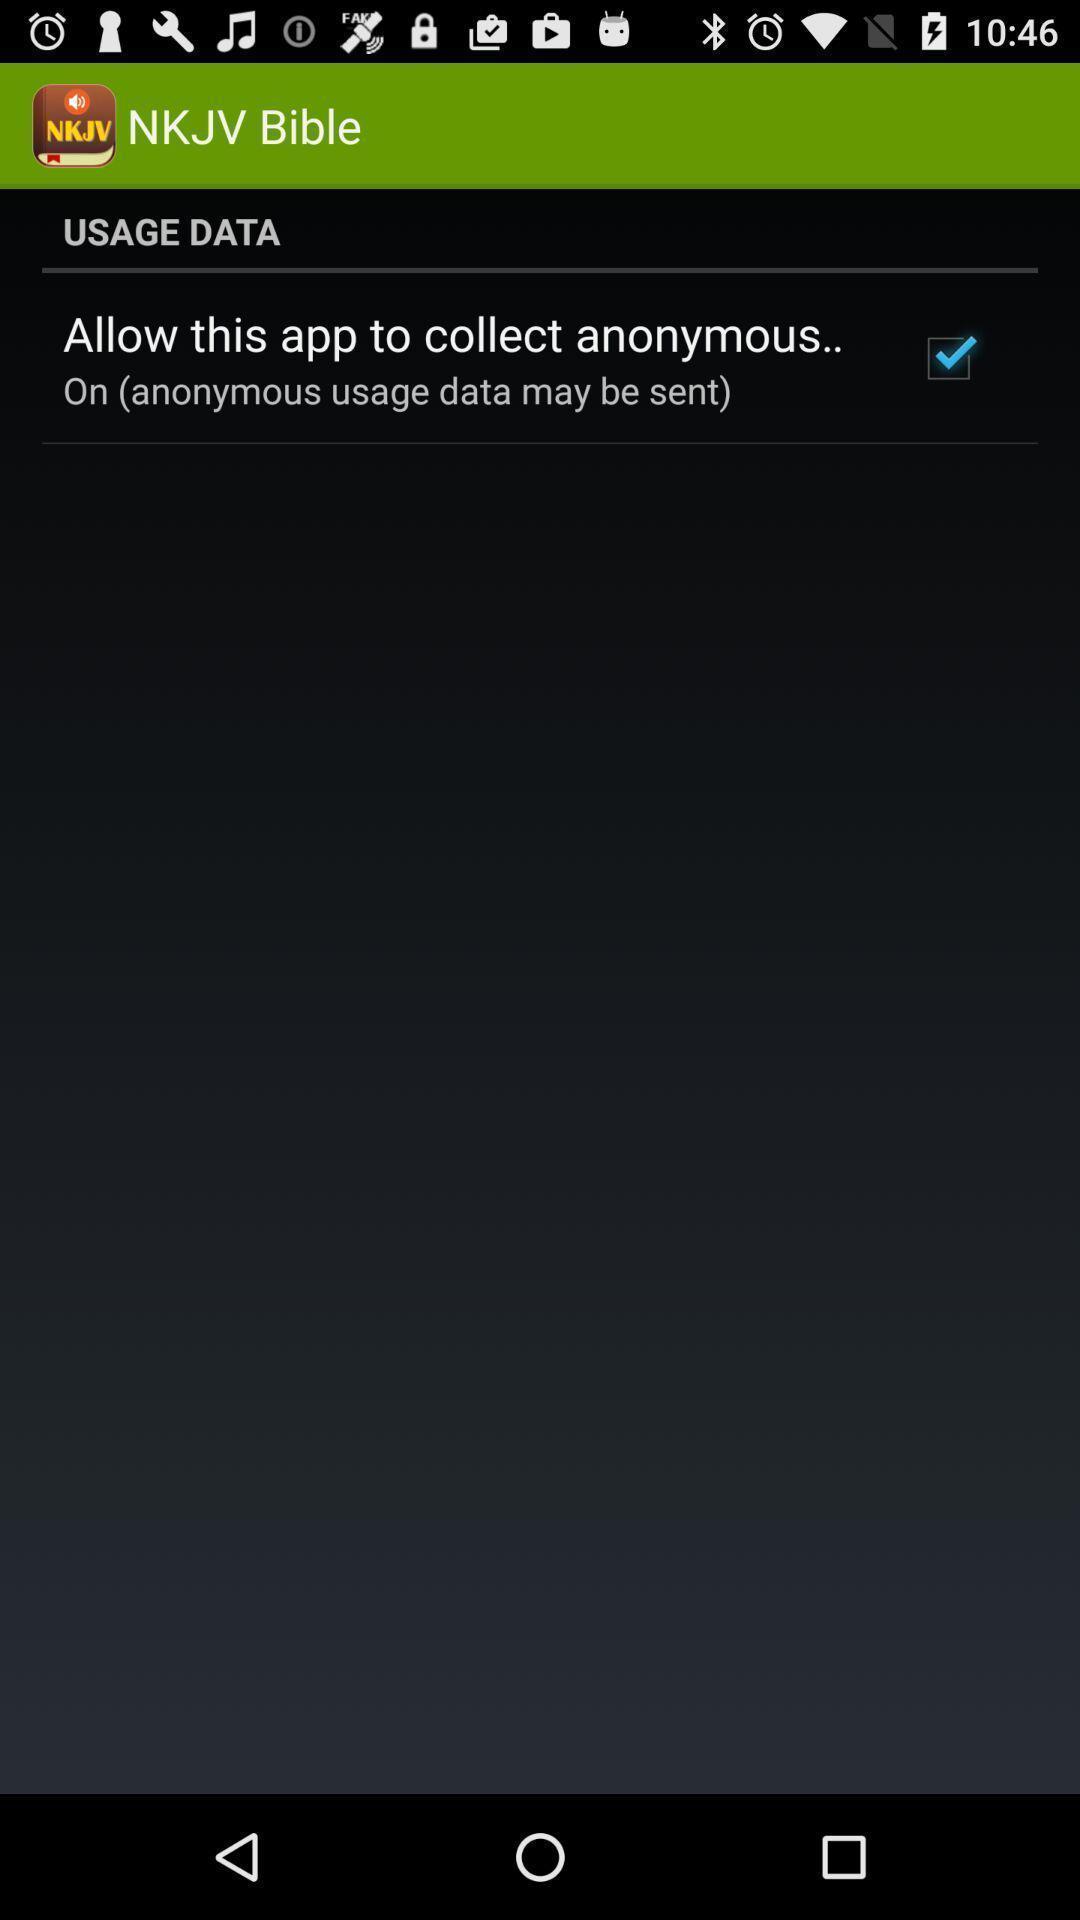Provide a textual representation of this image. Usage data page. 